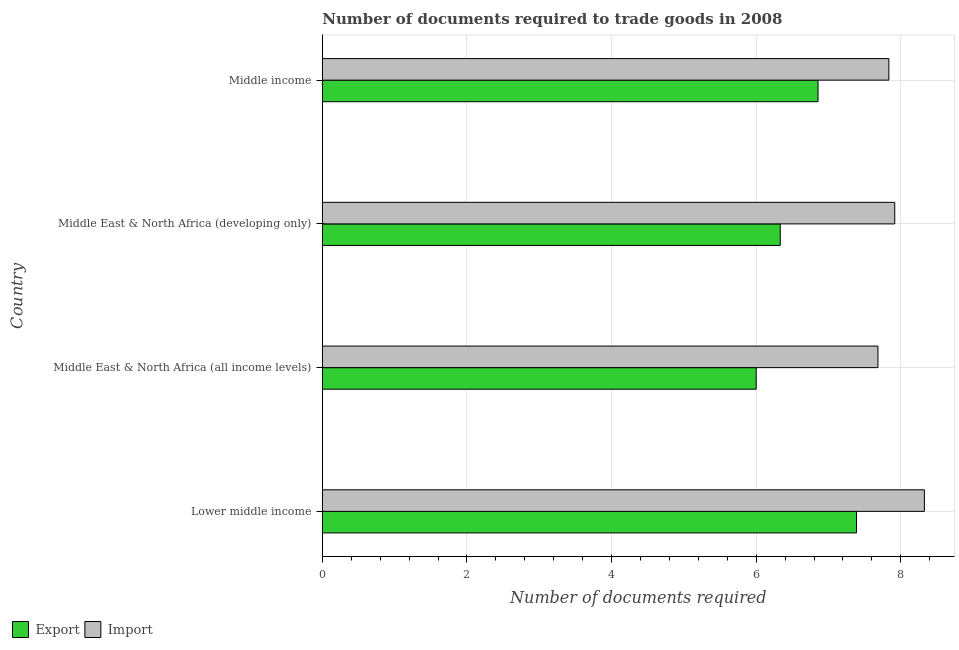How many different coloured bars are there?
Your response must be concise. 2. Are the number of bars per tick equal to the number of legend labels?
Your answer should be very brief. Yes. Are the number of bars on each tick of the Y-axis equal?
Your answer should be very brief. Yes. How many bars are there on the 2nd tick from the top?
Your response must be concise. 2. What is the label of the 3rd group of bars from the top?
Your response must be concise. Middle East & North Africa (all income levels). What is the number of documents required to export goods in Middle East & North Africa (all income levels)?
Give a very brief answer. 6. Across all countries, what is the maximum number of documents required to import goods?
Provide a succinct answer. 8.33. Across all countries, what is the minimum number of documents required to import goods?
Offer a very short reply. 7.68. In which country was the number of documents required to export goods maximum?
Your response must be concise. Lower middle income. In which country was the number of documents required to export goods minimum?
Provide a short and direct response. Middle East & North Africa (all income levels). What is the total number of documents required to export goods in the graph?
Ensure brevity in your answer.  26.58. What is the difference between the number of documents required to import goods in Lower middle income and that in Middle East & North Africa (developing only)?
Your response must be concise. 0.41. What is the difference between the number of documents required to export goods in Middle income and the number of documents required to import goods in Middle East & North Africa (all income levels)?
Offer a very short reply. -0.83. What is the average number of documents required to import goods per country?
Your answer should be compact. 7.94. What is the difference between the number of documents required to import goods and number of documents required to export goods in Middle East & North Africa (developing only)?
Your answer should be compact. 1.58. What is the ratio of the number of documents required to export goods in Lower middle income to that in Middle East & North Africa (developing only)?
Your answer should be very brief. 1.17. Is the difference between the number of documents required to export goods in Lower middle income and Middle East & North Africa (developing only) greater than the difference between the number of documents required to import goods in Lower middle income and Middle East & North Africa (developing only)?
Offer a terse response. Yes. What is the difference between the highest and the second highest number of documents required to export goods?
Provide a short and direct response. 0.53. What is the difference between the highest and the lowest number of documents required to export goods?
Provide a succinct answer. 1.39. In how many countries, is the number of documents required to import goods greater than the average number of documents required to import goods taken over all countries?
Keep it short and to the point. 1. Is the sum of the number of documents required to import goods in Lower middle income and Middle income greater than the maximum number of documents required to export goods across all countries?
Keep it short and to the point. Yes. What does the 1st bar from the top in Middle East & North Africa (developing only) represents?
Give a very brief answer. Import. What does the 1st bar from the bottom in Middle income represents?
Your response must be concise. Export. How many bars are there?
Ensure brevity in your answer.  8. Are all the bars in the graph horizontal?
Keep it short and to the point. Yes. Are the values on the major ticks of X-axis written in scientific E-notation?
Offer a very short reply. No. Does the graph contain any zero values?
Offer a terse response. No. Does the graph contain grids?
Your answer should be compact. Yes. How many legend labels are there?
Offer a very short reply. 2. How are the legend labels stacked?
Make the answer very short. Horizontal. What is the title of the graph?
Ensure brevity in your answer.  Number of documents required to trade goods in 2008. Does "Adolescent fertility rate" appear as one of the legend labels in the graph?
Ensure brevity in your answer.  No. What is the label or title of the X-axis?
Your answer should be very brief. Number of documents required. What is the label or title of the Y-axis?
Make the answer very short. Country. What is the Number of documents required of Export in Lower middle income?
Offer a very short reply. 7.39. What is the Number of documents required of Import in Lower middle income?
Your response must be concise. 8.33. What is the Number of documents required of Import in Middle East & North Africa (all income levels)?
Your answer should be compact. 7.68. What is the Number of documents required in Export in Middle East & North Africa (developing only)?
Your answer should be compact. 6.33. What is the Number of documents required of Import in Middle East & North Africa (developing only)?
Your answer should be very brief. 7.92. What is the Number of documents required of Export in Middle income?
Your answer should be compact. 6.86. What is the Number of documents required of Import in Middle income?
Offer a terse response. 7.84. Across all countries, what is the maximum Number of documents required of Export?
Provide a short and direct response. 7.39. Across all countries, what is the maximum Number of documents required of Import?
Make the answer very short. 8.33. Across all countries, what is the minimum Number of documents required of Export?
Offer a very short reply. 6. Across all countries, what is the minimum Number of documents required of Import?
Give a very brief answer. 7.68. What is the total Number of documents required in Export in the graph?
Offer a very short reply. 26.58. What is the total Number of documents required of Import in the graph?
Your answer should be compact. 31.76. What is the difference between the Number of documents required in Export in Lower middle income and that in Middle East & North Africa (all income levels)?
Make the answer very short. 1.39. What is the difference between the Number of documents required in Import in Lower middle income and that in Middle East & North Africa (all income levels)?
Keep it short and to the point. 0.64. What is the difference between the Number of documents required in Export in Lower middle income and that in Middle East & North Africa (developing only)?
Make the answer very short. 1.05. What is the difference between the Number of documents required of Import in Lower middle income and that in Middle East & North Africa (developing only)?
Make the answer very short. 0.41. What is the difference between the Number of documents required in Export in Lower middle income and that in Middle income?
Provide a short and direct response. 0.53. What is the difference between the Number of documents required in Import in Lower middle income and that in Middle income?
Keep it short and to the point. 0.49. What is the difference between the Number of documents required in Import in Middle East & North Africa (all income levels) and that in Middle East & North Africa (developing only)?
Your response must be concise. -0.23. What is the difference between the Number of documents required in Export in Middle East & North Africa (all income levels) and that in Middle income?
Your response must be concise. -0.86. What is the difference between the Number of documents required of Import in Middle East & North Africa (all income levels) and that in Middle income?
Ensure brevity in your answer.  -0.15. What is the difference between the Number of documents required of Export in Middle East & North Africa (developing only) and that in Middle income?
Offer a very short reply. -0.52. What is the difference between the Number of documents required of Import in Middle East & North Africa (developing only) and that in Middle income?
Keep it short and to the point. 0.08. What is the difference between the Number of documents required of Export in Lower middle income and the Number of documents required of Import in Middle East & North Africa (all income levels)?
Your answer should be compact. -0.3. What is the difference between the Number of documents required in Export in Lower middle income and the Number of documents required in Import in Middle East & North Africa (developing only)?
Offer a very short reply. -0.53. What is the difference between the Number of documents required in Export in Lower middle income and the Number of documents required in Import in Middle income?
Provide a short and direct response. -0.45. What is the difference between the Number of documents required in Export in Middle East & North Africa (all income levels) and the Number of documents required in Import in Middle East & North Africa (developing only)?
Give a very brief answer. -1.92. What is the difference between the Number of documents required of Export in Middle East & North Africa (all income levels) and the Number of documents required of Import in Middle income?
Provide a succinct answer. -1.84. What is the difference between the Number of documents required in Export in Middle East & North Africa (developing only) and the Number of documents required in Import in Middle income?
Provide a succinct answer. -1.5. What is the average Number of documents required of Export per country?
Your response must be concise. 6.64. What is the average Number of documents required in Import per country?
Offer a terse response. 7.94. What is the difference between the Number of documents required of Export and Number of documents required of Import in Lower middle income?
Give a very brief answer. -0.94. What is the difference between the Number of documents required in Export and Number of documents required in Import in Middle East & North Africa (all income levels)?
Your answer should be compact. -1.68. What is the difference between the Number of documents required in Export and Number of documents required in Import in Middle East & North Africa (developing only)?
Provide a succinct answer. -1.58. What is the difference between the Number of documents required of Export and Number of documents required of Import in Middle income?
Offer a very short reply. -0.98. What is the ratio of the Number of documents required of Export in Lower middle income to that in Middle East & North Africa (all income levels)?
Your answer should be very brief. 1.23. What is the ratio of the Number of documents required of Import in Lower middle income to that in Middle East & North Africa (all income levels)?
Make the answer very short. 1.08. What is the ratio of the Number of documents required of Export in Lower middle income to that in Middle East & North Africa (developing only)?
Make the answer very short. 1.17. What is the ratio of the Number of documents required of Import in Lower middle income to that in Middle East & North Africa (developing only)?
Make the answer very short. 1.05. What is the ratio of the Number of documents required of Export in Lower middle income to that in Middle income?
Provide a succinct answer. 1.08. What is the ratio of the Number of documents required of Import in Lower middle income to that in Middle income?
Make the answer very short. 1.06. What is the ratio of the Number of documents required in Import in Middle East & North Africa (all income levels) to that in Middle East & North Africa (developing only)?
Provide a short and direct response. 0.97. What is the ratio of the Number of documents required of Export in Middle East & North Africa (all income levels) to that in Middle income?
Ensure brevity in your answer.  0.88. What is the ratio of the Number of documents required of Import in Middle East & North Africa (all income levels) to that in Middle income?
Ensure brevity in your answer.  0.98. What is the ratio of the Number of documents required of Export in Middle East & North Africa (developing only) to that in Middle income?
Your answer should be compact. 0.92. What is the ratio of the Number of documents required in Import in Middle East & North Africa (developing only) to that in Middle income?
Provide a succinct answer. 1.01. What is the difference between the highest and the second highest Number of documents required of Export?
Keep it short and to the point. 0.53. What is the difference between the highest and the second highest Number of documents required in Import?
Keep it short and to the point. 0.41. What is the difference between the highest and the lowest Number of documents required in Export?
Your response must be concise. 1.39. What is the difference between the highest and the lowest Number of documents required of Import?
Provide a succinct answer. 0.64. 